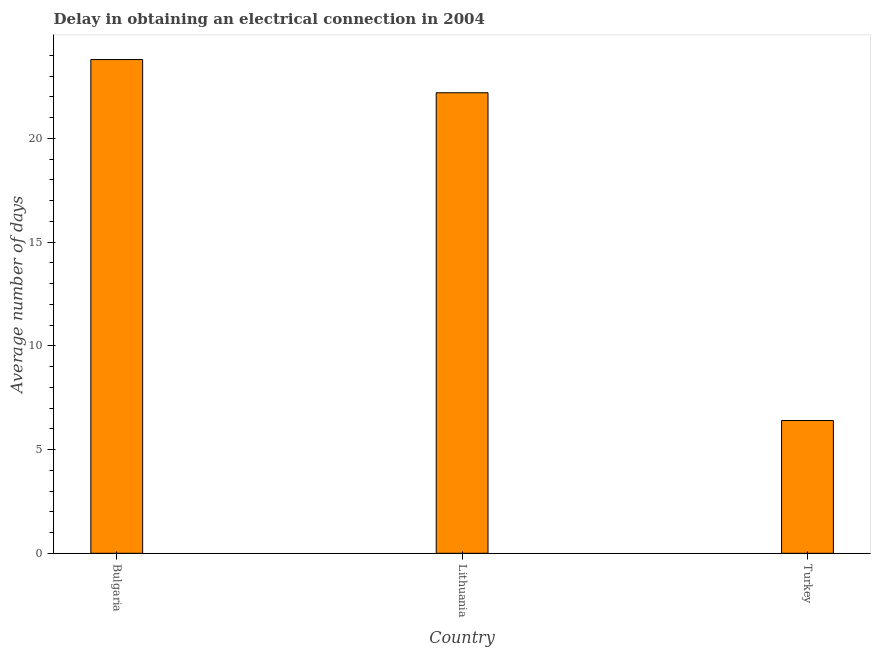Does the graph contain any zero values?
Your response must be concise. No. Does the graph contain grids?
Ensure brevity in your answer.  No. What is the title of the graph?
Offer a very short reply. Delay in obtaining an electrical connection in 2004. What is the label or title of the Y-axis?
Your answer should be very brief. Average number of days. What is the dalay in electrical connection in Lithuania?
Provide a succinct answer. 22.2. Across all countries, what is the maximum dalay in electrical connection?
Make the answer very short. 23.8. Across all countries, what is the minimum dalay in electrical connection?
Provide a succinct answer. 6.4. In which country was the dalay in electrical connection maximum?
Offer a very short reply. Bulgaria. In which country was the dalay in electrical connection minimum?
Keep it short and to the point. Turkey. What is the sum of the dalay in electrical connection?
Give a very brief answer. 52.4. What is the difference between the dalay in electrical connection in Bulgaria and Lithuania?
Provide a short and direct response. 1.6. What is the average dalay in electrical connection per country?
Your answer should be very brief. 17.47. What is the median dalay in electrical connection?
Offer a terse response. 22.2. What is the ratio of the dalay in electrical connection in Lithuania to that in Turkey?
Keep it short and to the point. 3.47. Is the difference between the dalay in electrical connection in Bulgaria and Lithuania greater than the difference between any two countries?
Offer a terse response. No. What is the difference between the highest and the second highest dalay in electrical connection?
Offer a very short reply. 1.6. Are the values on the major ticks of Y-axis written in scientific E-notation?
Your answer should be compact. No. What is the Average number of days of Bulgaria?
Your answer should be very brief. 23.8. What is the Average number of days of Turkey?
Your answer should be very brief. 6.4. What is the difference between the Average number of days in Bulgaria and Lithuania?
Give a very brief answer. 1.6. What is the difference between the Average number of days in Bulgaria and Turkey?
Your response must be concise. 17.4. What is the difference between the Average number of days in Lithuania and Turkey?
Offer a terse response. 15.8. What is the ratio of the Average number of days in Bulgaria to that in Lithuania?
Keep it short and to the point. 1.07. What is the ratio of the Average number of days in Bulgaria to that in Turkey?
Ensure brevity in your answer.  3.72. What is the ratio of the Average number of days in Lithuania to that in Turkey?
Give a very brief answer. 3.47. 